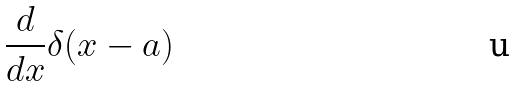<formula> <loc_0><loc_0><loc_500><loc_500>\frac { d } { d x } \delta ( x - a )</formula> 